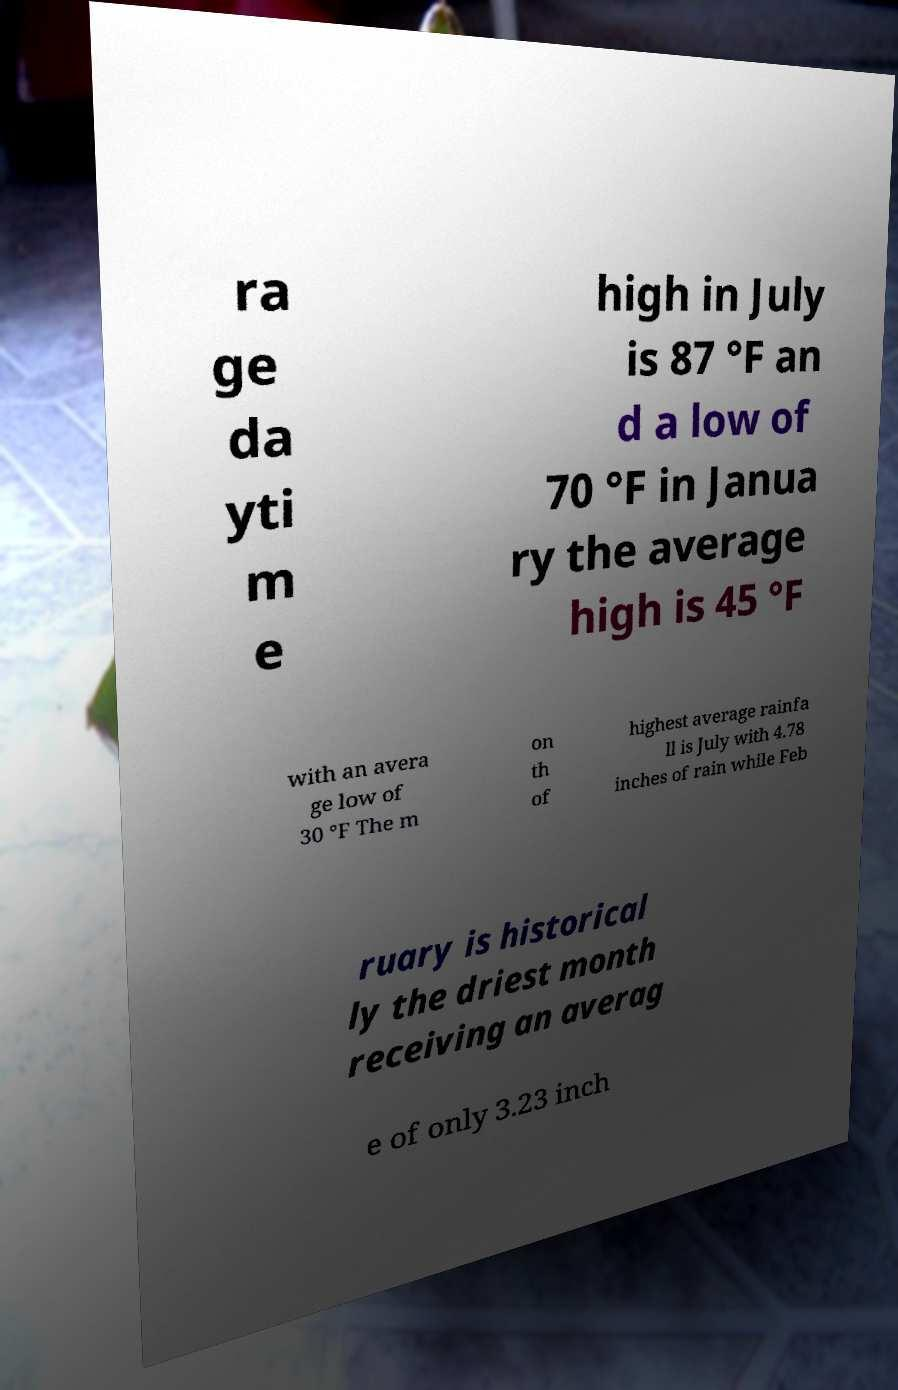Please read and relay the text visible in this image. What does it say? ra ge da yti m e high in July is 87 °F an d a low of 70 °F in Janua ry the average high is 45 °F with an avera ge low of 30 °F The m on th of highest average rainfa ll is July with 4.78 inches of rain while Feb ruary is historical ly the driest month receiving an averag e of only 3.23 inch 